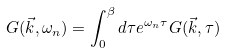Convert formula to latex. <formula><loc_0><loc_0><loc_500><loc_500>G ( \vec { k } , \omega _ { n } ) = \int _ { 0 } ^ { \beta } d \tau e ^ { \omega _ { n } \tau } G ( \vec { k } , \tau )</formula> 